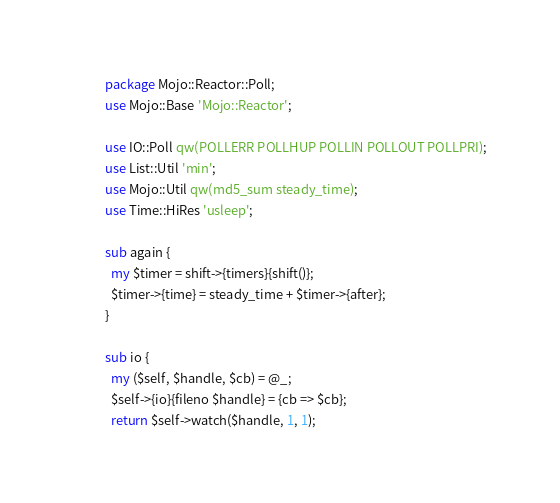<code> <loc_0><loc_0><loc_500><loc_500><_Perl_>package Mojo::Reactor::Poll;
use Mojo::Base 'Mojo::Reactor';

use IO::Poll qw(POLLERR POLLHUP POLLIN POLLOUT POLLPRI);
use List::Util 'min';
use Mojo::Util qw(md5_sum steady_time);
use Time::HiRes 'usleep';

sub again {
  my $timer = shift->{timers}{shift()};
  $timer->{time} = steady_time + $timer->{after};
}

sub io {
  my ($self, $handle, $cb) = @_;
  $self->{io}{fileno $handle} = {cb => $cb};
  return $self->watch($handle, 1, 1);</code> 